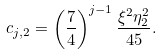<formula> <loc_0><loc_0><loc_500><loc_500>c _ { j , 2 } = \left ( \frac { 7 } { 4 } \right ) ^ { j - 1 } \frac { \xi ^ { 2 } \eta _ { 2 } ^ { 2 } } { 4 5 } .</formula> 